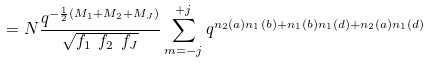<formula> <loc_0><loc_0><loc_500><loc_500>= N \frac { q ^ { - \frac { 1 } { 2 } ( M _ { 1 } + M _ { 2 } + M _ { J } ) } } { \sqrt { f _ { 1 } \ f _ { 2 } \ f _ { J } } } \sum ^ { + j } _ { m = - j } q ^ { n _ { 2 } ( a ) n _ { 1 } ( b ) + n _ { 1 } ( b ) n _ { 1 } ( d ) + n _ { 2 } ( a ) n _ { 1 } ( d ) }</formula> 